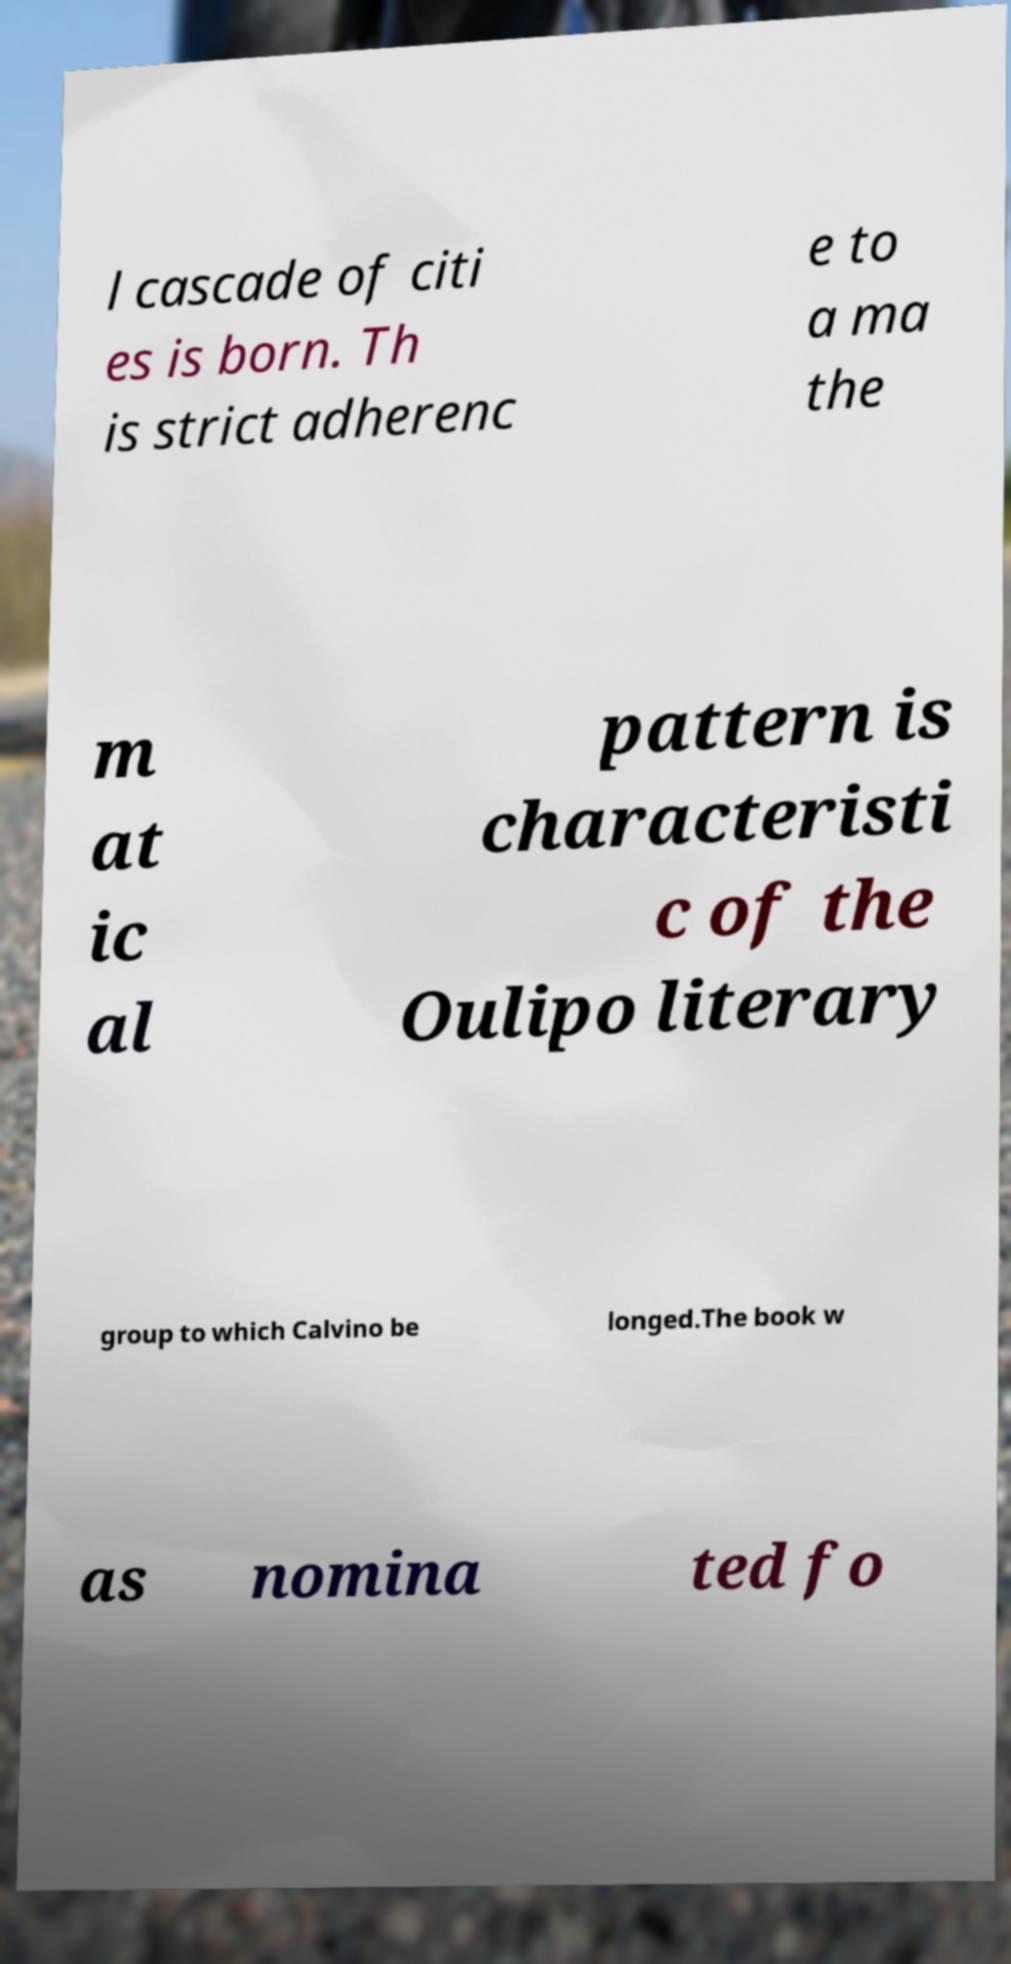There's text embedded in this image that I need extracted. Can you transcribe it verbatim? l cascade of citi es is born. Th is strict adherenc e to a ma the m at ic al pattern is characteristi c of the Oulipo literary group to which Calvino be longed.The book w as nomina ted fo 